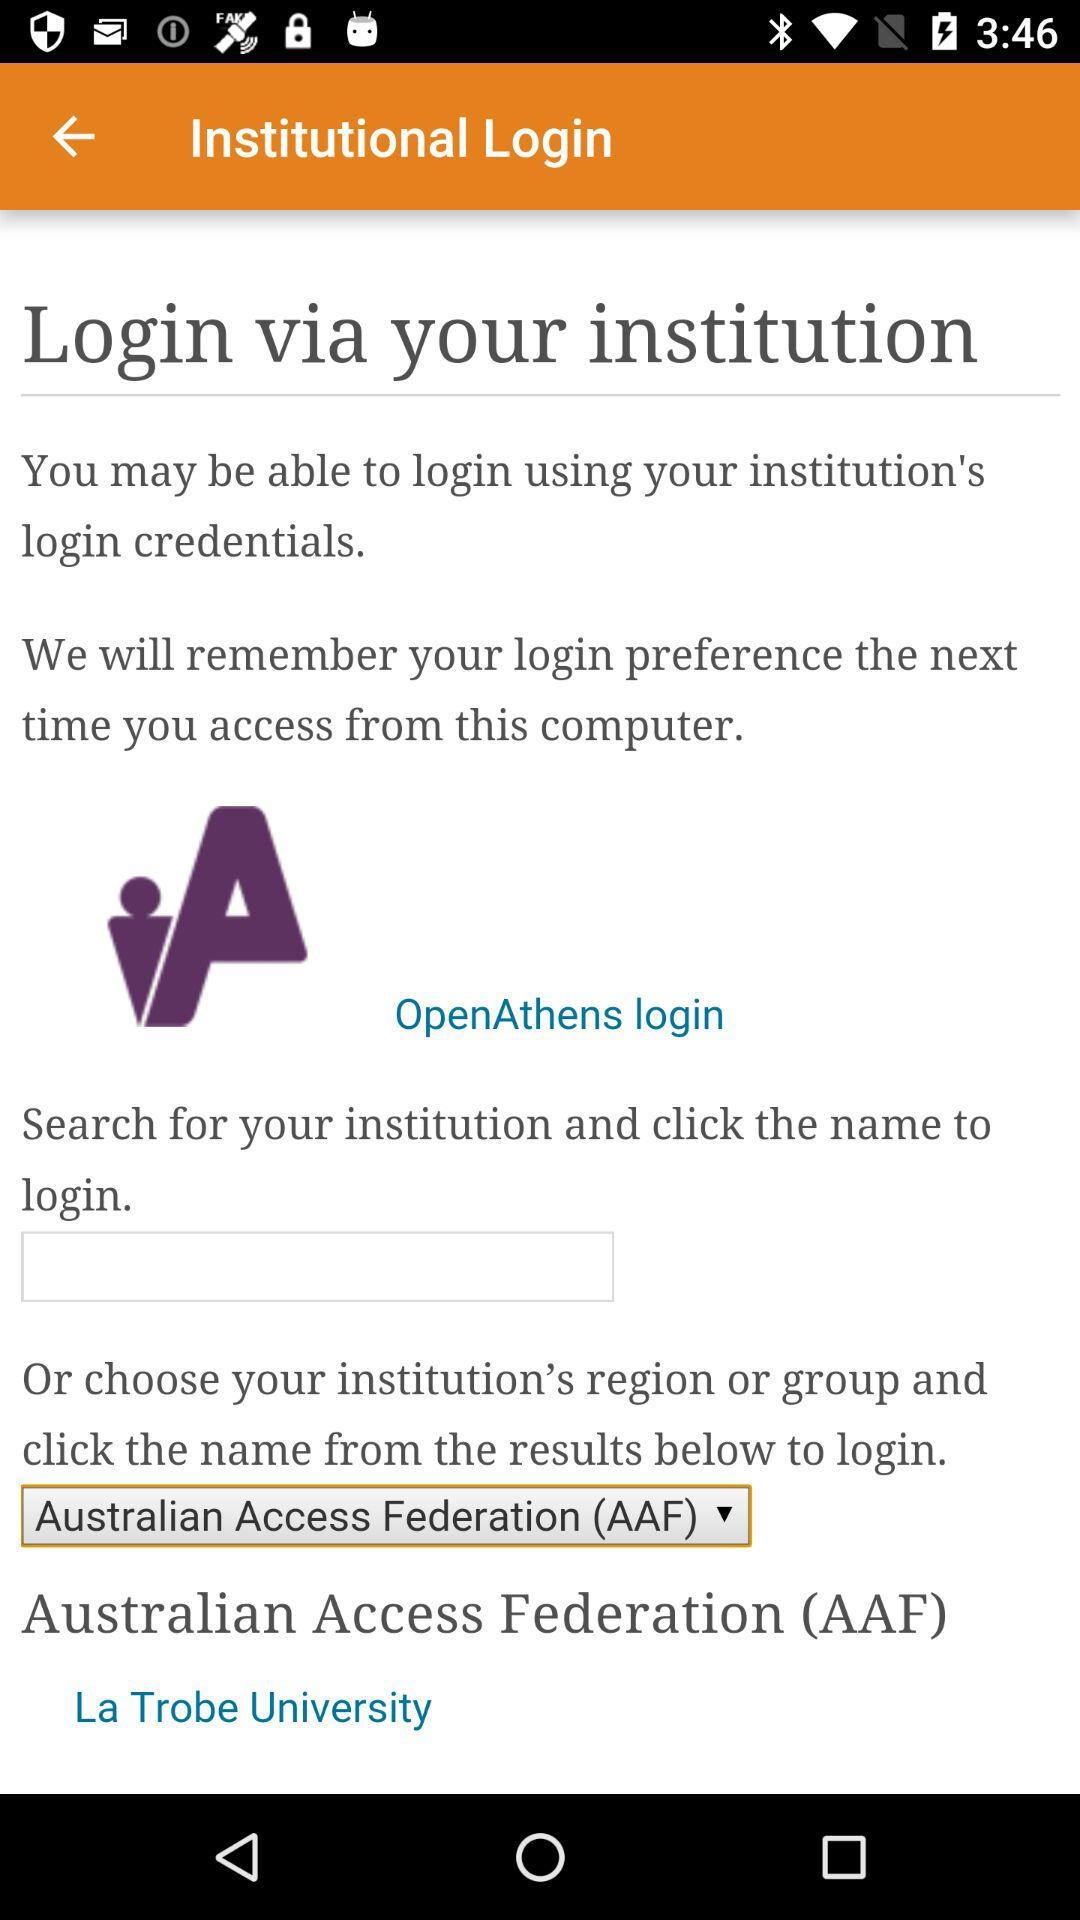Where in Australia is La Trobe University?
When the provided information is insufficient, respond with <no answer>. <no answer> 